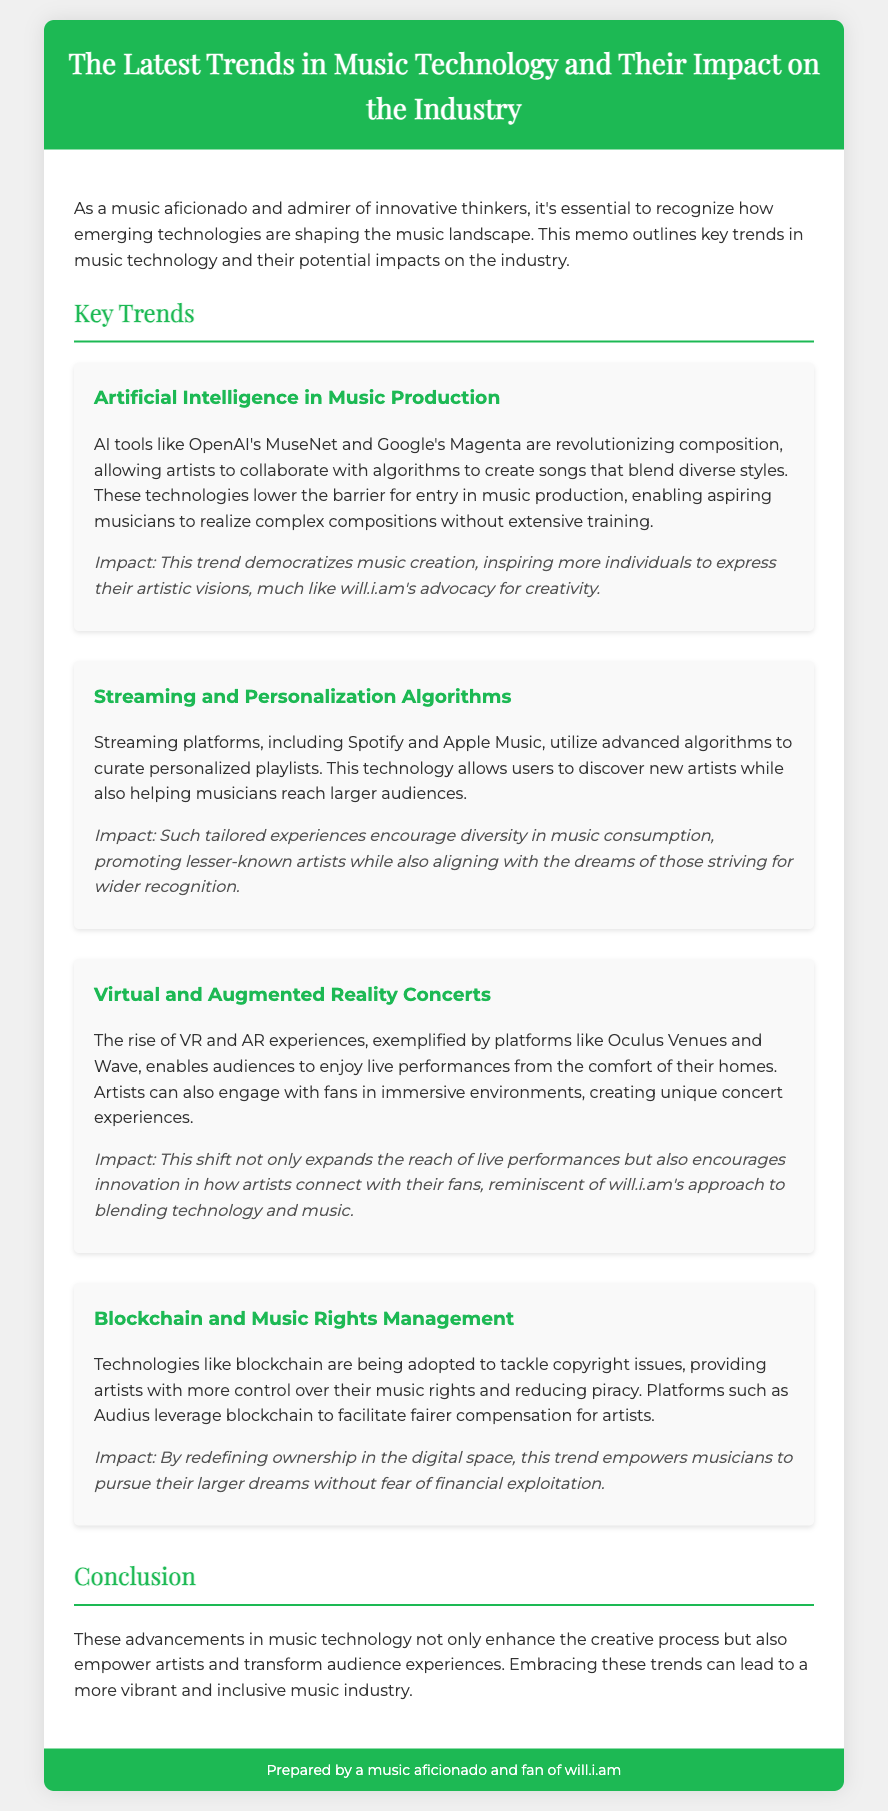What are two AI tools mentioned? The document lists OpenAI's MuseNet and Google's Magenta as AI tools revolutionizing music composition.
Answer: OpenAI's MuseNet, Google's Magenta What is the impact of AI on music creation? The memo states that AI democratizes music creation by enabling aspiring musicians to realize complex compositions without extensive training.
Answer: Democratizes music creation Name one streaming platform discussed. The memo mentions Spotify and Apple Music as streaming platforms that use algorithms for personalized playlists.
Answer: Spotify What technology is being used for concert experiences? The document highlights the use of VR and AR for enhancing concert experiences.
Answer: VR and AR Which technology is addressing copyright issues in music? The memo talks about blockchain technology being adopted to tackle copyright issues.
Answer: Blockchain How do personalization algorithms benefit musicians? According to the memo, personalization algorithms help musicians reach larger audiences while also allowing users to discover new artists.
Answer: Reach larger audiences What is the conclusion about advancements in music technology? The document concludes that advancements in music technology enhance the creative process and empower artists.
Answer: Enhance the creative process What kind of experiences do platforms like Oculus Venues provide? The memo states that those platforms provide immersive concert experiences to users.
Answer: Immersive concert experiences 